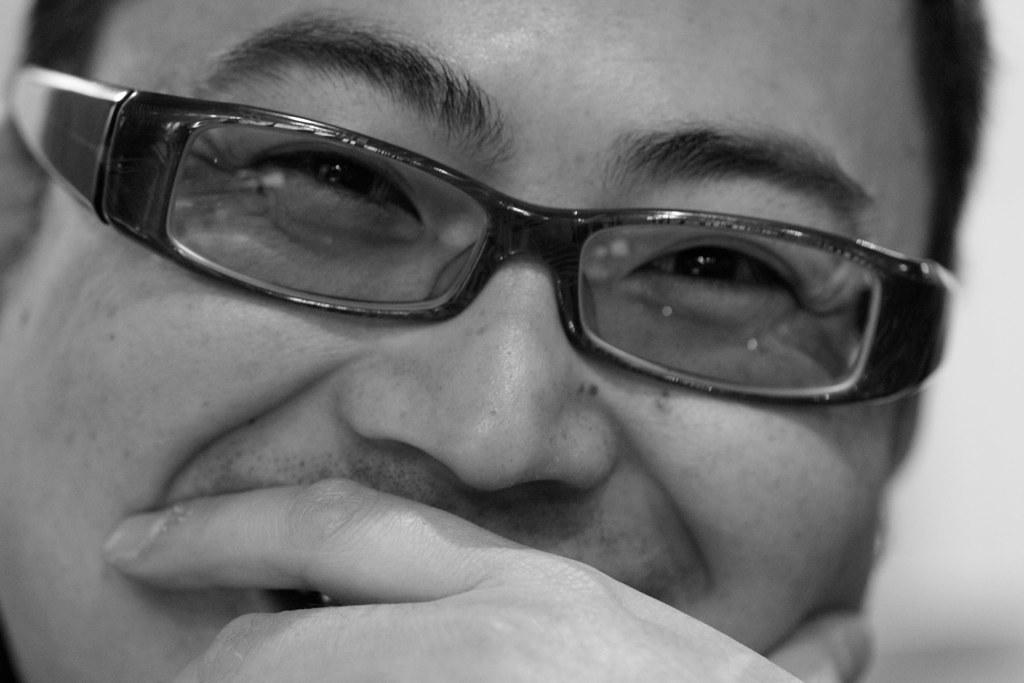What is the main subject of the image? The main subject of the image is a man. What can be observed about the man's appearance? The man is wearing spectacles. What is the man's facial expression in the image? The man is smiling. What type of leather is the squirrel using to fuel its vehicle in the image? There is no squirrel or vehicle present in the image, so it is not possible to determine what type of leather might be used for fuel. 